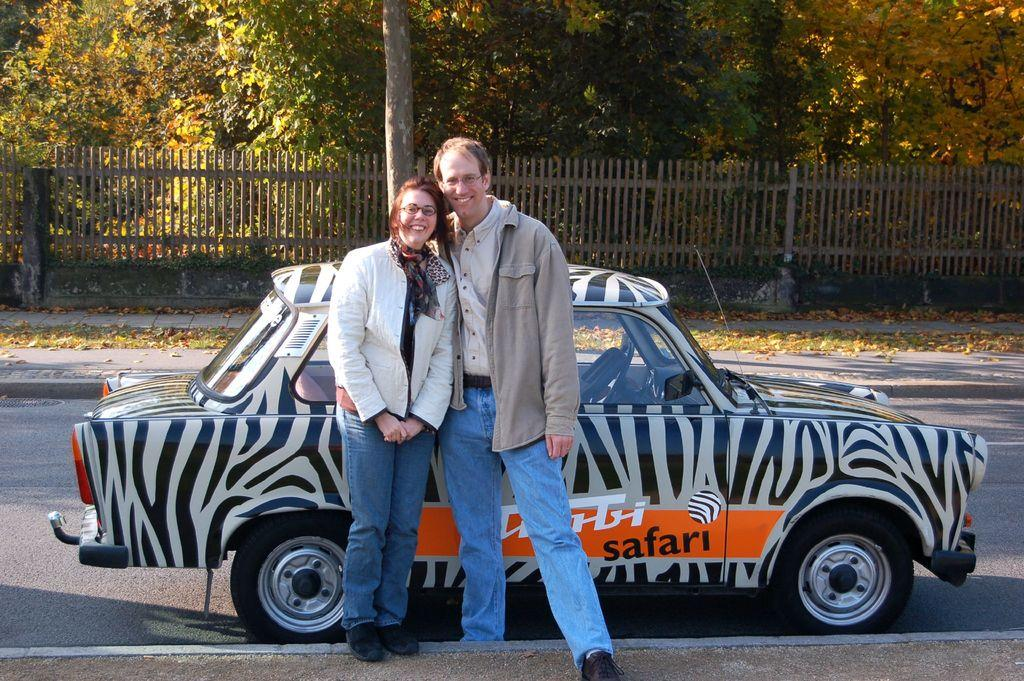What are the people in the image doing? The man and woman in the image are standing and smiling. What can be seen on the road in the image? There is a vehicle on the road in the image. What is visible in the background of the image? There are trees and a fence in the background of the image. What type of tub is visible in the image? There is no tub present in the image. Can you tell me which political representative is standing with the woman in the image? There is no indication of a political representative in the image; it simply features a man and a woman standing and smiling. 